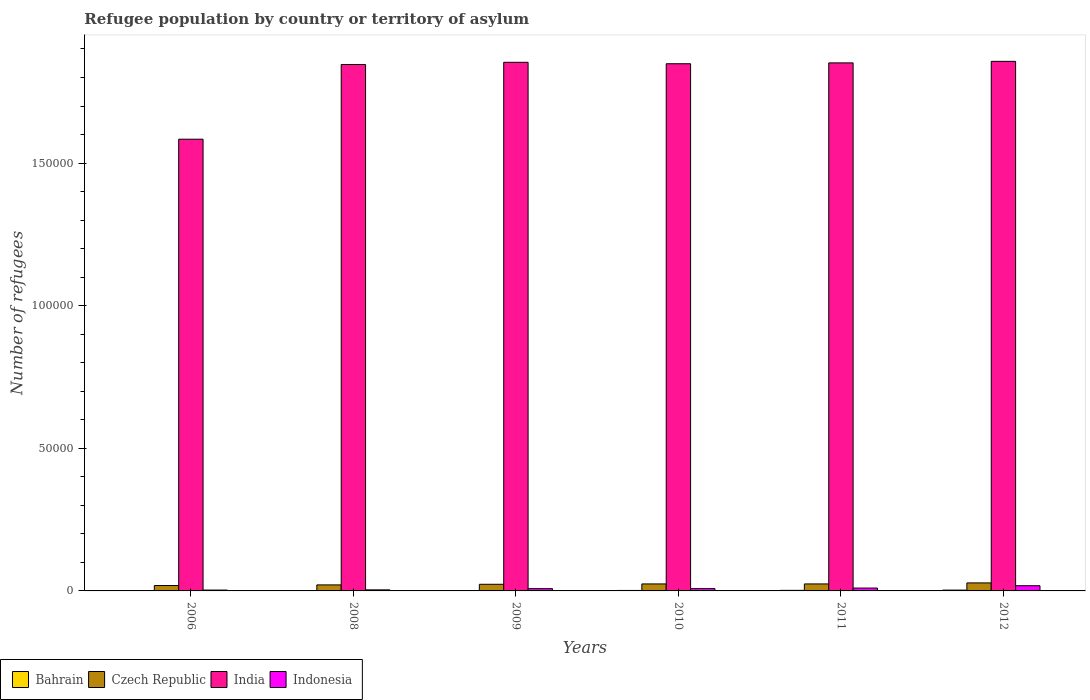How many different coloured bars are there?
Offer a very short reply. 4. How many groups of bars are there?
Offer a terse response. 6. Are the number of bars per tick equal to the number of legend labels?
Give a very brief answer. Yes. In how many cases, is the number of bars for a given year not equal to the number of legend labels?
Your answer should be compact. 0. What is the number of refugees in Indonesia in 2008?
Provide a succinct answer. 369. Across all years, what is the maximum number of refugees in Indonesia?
Your answer should be very brief. 1819. In which year was the number of refugees in Indonesia maximum?
Give a very brief answer. 2012. What is the total number of refugees in Indonesia in the graph?
Your response must be concise. 5104. What is the difference between the number of refugees in Indonesia in 2010 and that in 2011?
Your answer should be compact. -195. What is the difference between the number of refugees in Indonesia in 2009 and the number of refugees in India in 2012?
Keep it short and to the point. -1.85e+05. What is the average number of refugees in India per year?
Provide a succinct answer. 1.81e+05. In the year 2011, what is the difference between the number of refugees in Bahrain and number of refugees in India?
Ensure brevity in your answer.  -1.85e+05. What is the ratio of the number of refugees in Indonesia in 2009 to that in 2012?
Make the answer very short. 0.44. Is the difference between the number of refugees in Bahrain in 2008 and 2009 greater than the difference between the number of refugees in India in 2008 and 2009?
Ensure brevity in your answer.  Yes. What is the difference between the highest and the lowest number of refugees in Indonesia?
Your answer should be very brief. 1518. Is the sum of the number of refugees in Bahrain in 2010 and 2011 greater than the maximum number of refugees in Czech Republic across all years?
Offer a very short reply. No. Is it the case that in every year, the sum of the number of refugees in Indonesia and number of refugees in India is greater than the sum of number of refugees in Czech Republic and number of refugees in Bahrain?
Provide a short and direct response. No. What does the 4th bar from the right in 2011 represents?
Your answer should be compact. Bahrain. Is it the case that in every year, the sum of the number of refugees in India and number of refugees in Bahrain is greater than the number of refugees in Czech Republic?
Offer a very short reply. Yes. How many years are there in the graph?
Give a very brief answer. 6. What is the difference between two consecutive major ticks on the Y-axis?
Keep it short and to the point. 5.00e+04. Are the values on the major ticks of Y-axis written in scientific E-notation?
Offer a very short reply. No. Does the graph contain any zero values?
Your answer should be compact. No. Does the graph contain grids?
Your answer should be very brief. No. How many legend labels are there?
Make the answer very short. 4. How are the legend labels stacked?
Offer a terse response. Horizontal. What is the title of the graph?
Ensure brevity in your answer.  Refugee population by country or territory of asylum. What is the label or title of the Y-axis?
Give a very brief answer. Number of refugees. What is the Number of refugees in Czech Republic in 2006?
Offer a terse response. 1887. What is the Number of refugees of India in 2006?
Offer a terse response. 1.58e+05. What is the Number of refugees of Indonesia in 2006?
Offer a terse response. 301. What is the Number of refugees in Bahrain in 2008?
Provide a short and direct response. 48. What is the Number of refugees in Czech Republic in 2008?
Provide a succinct answer. 2110. What is the Number of refugees in India in 2008?
Your answer should be compact. 1.85e+05. What is the Number of refugees in Indonesia in 2008?
Your response must be concise. 369. What is the Number of refugees in Bahrain in 2009?
Your answer should be compact. 139. What is the Number of refugees of Czech Republic in 2009?
Your answer should be very brief. 2323. What is the Number of refugees in India in 2009?
Make the answer very short. 1.85e+05. What is the Number of refugees of Indonesia in 2009?
Ensure brevity in your answer.  798. What is the Number of refugees in Bahrain in 2010?
Ensure brevity in your answer.  165. What is the Number of refugees in Czech Republic in 2010?
Your answer should be very brief. 2449. What is the Number of refugees in India in 2010?
Provide a succinct answer. 1.85e+05. What is the Number of refugees in Indonesia in 2010?
Your answer should be compact. 811. What is the Number of refugees in Bahrain in 2011?
Keep it short and to the point. 199. What is the Number of refugees of Czech Republic in 2011?
Provide a succinct answer. 2449. What is the Number of refugees of India in 2011?
Offer a very short reply. 1.85e+05. What is the Number of refugees of Indonesia in 2011?
Your response must be concise. 1006. What is the Number of refugees in Bahrain in 2012?
Offer a very short reply. 289. What is the Number of refugees in Czech Republic in 2012?
Your response must be concise. 2805. What is the Number of refugees in India in 2012?
Offer a very short reply. 1.86e+05. What is the Number of refugees in Indonesia in 2012?
Offer a very short reply. 1819. Across all years, what is the maximum Number of refugees in Bahrain?
Your answer should be very brief. 289. Across all years, what is the maximum Number of refugees in Czech Republic?
Make the answer very short. 2805. Across all years, what is the maximum Number of refugees in India?
Offer a terse response. 1.86e+05. Across all years, what is the maximum Number of refugees in Indonesia?
Keep it short and to the point. 1819. Across all years, what is the minimum Number of refugees of Bahrain?
Provide a short and direct response. 1. Across all years, what is the minimum Number of refugees of Czech Republic?
Keep it short and to the point. 1887. Across all years, what is the minimum Number of refugees of India?
Ensure brevity in your answer.  1.58e+05. Across all years, what is the minimum Number of refugees in Indonesia?
Give a very brief answer. 301. What is the total Number of refugees in Bahrain in the graph?
Your answer should be compact. 841. What is the total Number of refugees in Czech Republic in the graph?
Provide a succinct answer. 1.40e+04. What is the total Number of refugees in India in the graph?
Offer a terse response. 1.08e+06. What is the total Number of refugees in Indonesia in the graph?
Keep it short and to the point. 5104. What is the difference between the Number of refugees in Bahrain in 2006 and that in 2008?
Make the answer very short. -47. What is the difference between the Number of refugees in Czech Republic in 2006 and that in 2008?
Provide a succinct answer. -223. What is the difference between the Number of refugees in India in 2006 and that in 2008?
Keep it short and to the point. -2.62e+04. What is the difference between the Number of refugees of Indonesia in 2006 and that in 2008?
Your response must be concise. -68. What is the difference between the Number of refugees of Bahrain in 2006 and that in 2009?
Your answer should be compact. -138. What is the difference between the Number of refugees in Czech Republic in 2006 and that in 2009?
Provide a succinct answer. -436. What is the difference between the Number of refugees in India in 2006 and that in 2009?
Give a very brief answer. -2.70e+04. What is the difference between the Number of refugees in Indonesia in 2006 and that in 2009?
Offer a terse response. -497. What is the difference between the Number of refugees in Bahrain in 2006 and that in 2010?
Your answer should be compact. -164. What is the difference between the Number of refugees in Czech Republic in 2006 and that in 2010?
Offer a very short reply. -562. What is the difference between the Number of refugees of India in 2006 and that in 2010?
Make the answer very short. -2.65e+04. What is the difference between the Number of refugees of Indonesia in 2006 and that in 2010?
Keep it short and to the point. -510. What is the difference between the Number of refugees in Bahrain in 2006 and that in 2011?
Your response must be concise. -198. What is the difference between the Number of refugees of Czech Republic in 2006 and that in 2011?
Offer a very short reply. -562. What is the difference between the Number of refugees of India in 2006 and that in 2011?
Your answer should be compact. -2.68e+04. What is the difference between the Number of refugees in Indonesia in 2006 and that in 2011?
Keep it short and to the point. -705. What is the difference between the Number of refugees of Bahrain in 2006 and that in 2012?
Give a very brief answer. -288. What is the difference between the Number of refugees in Czech Republic in 2006 and that in 2012?
Ensure brevity in your answer.  -918. What is the difference between the Number of refugees in India in 2006 and that in 2012?
Offer a very short reply. -2.73e+04. What is the difference between the Number of refugees in Indonesia in 2006 and that in 2012?
Provide a short and direct response. -1518. What is the difference between the Number of refugees in Bahrain in 2008 and that in 2009?
Your answer should be compact. -91. What is the difference between the Number of refugees of Czech Republic in 2008 and that in 2009?
Ensure brevity in your answer.  -213. What is the difference between the Number of refugees of India in 2008 and that in 2009?
Your response must be concise. -780. What is the difference between the Number of refugees in Indonesia in 2008 and that in 2009?
Provide a succinct answer. -429. What is the difference between the Number of refugees in Bahrain in 2008 and that in 2010?
Keep it short and to the point. -117. What is the difference between the Number of refugees in Czech Republic in 2008 and that in 2010?
Offer a terse response. -339. What is the difference between the Number of refugees in India in 2008 and that in 2010?
Offer a very short reply. -278. What is the difference between the Number of refugees of Indonesia in 2008 and that in 2010?
Provide a succinct answer. -442. What is the difference between the Number of refugees of Bahrain in 2008 and that in 2011?
Give a very brief answer. -151. What is the difference between the Number of refugees of Czech Republic in 2008 and that in 2011?
Your answer should be compact. -339. What is the difference between the Number of refugees in India in 2008 and that in 2011?
Provide a short and direct response. -575. What is the difference between the Number of refugees in Indonesia in 2008 and that in 2011?
Give a very brief answer. -637. What is the difference between the Number of refugees of Bahrain in 2008 and that in 2012?
Offer a very short reply. -241. What is the difference between the Number of refugees in Czech Republic in 2008 and that in 2012?
Make the answer very short. -695. What is the difference between the Number of refugees of India in 2008 and that in 2012?
Keep it short and to the point. -1113. What is the difference between the Number of refugees in Indonesia in 2008 and that in 2012?
Your response must be concise. -1450. What is the difference between the Number of refugees in Czech Republic in 2009 and that in 2010?
Your answer should be very brief. -126. What is the difference between the Number of refugees of India in 2009 and that in 2010?
Provide a succinct answer. 502. What is the difference between the Number of refugees in Bahrain in 2009 and that in 2011?
Your answer should be compact. -60. What is the difference between the Number of refugees in Czech Republic in 2009 and that in 2011?
Your answer should be very brief. -126. What is the difference between the Number of refugees in India in 2009 and that in 2011?
Keep it short and to the point. 205. What is the difference between the Number of refugees in Indonesia in 2009 and that in 2011?
Offer a very short reply. -208. What is the difference between the Number of refugees in Bahrain in 2009 and that in 2012?
Your answer should be very brief. -150. What is the difference between the Number of refugees in Czech Republic in 2009 and that in 2012?
Provide a short and direct response. -482. What is the difference between the Number of refugees of India in 2009 and that in 2012?
Keep it short and to the point. -333. What is the difference between the Number of refugees in Indonesia in 2009 and that in 2012?
Offer a very short reply. -1021. What is the difference between the Number of refugees of Bahrain in 2010 and that in 2011?
Your answer should be very brief. -34. What is the difference between the Number of refugees of Czech Republic in 2010 and that in 2011?
Offer a terse response. 0. What is the difference between the Number of refugees in India in 2010 and that in 2011?
Your answer should be compact. -297. What is the difference between the Number of refugees of Indonesia in 2010 and that in 2011?
Provide a short and direct response. -195. What is the difference between the Number of refugees in Bahrain in 2010 and that in 2012?
Ensure brevity in your answer.  -124. What is the difference between the Number of refugees of Czech Republic in 2010 and that in 2012?
Your answer should be compact. -356. What is the difference between the Number of refugees of India in 2010 and that in 2012?
Make the answer very short. -835. What is the difference between the Number of refugees in Indonesia in 2010 and that in 2012?
Provide a short and direct response. -1008. What is the difference between the Number of refugees of Bahrain in 2011 and that in 2012?
Your answer should be very brief. -90. What is the difference between the Number of refugees of Czech Republic in 2011 and that in 2012?
Your answer should be compact. -356. What is the difference between the Number of refugees of India in 2011 and that in 2012?
Offer a very short reply. -538. What is the difference between the Number of refugees of Indonesia in 2011 and that in 2012?
Keep it short and to the point. -813. What is the difference between the Number of refugees of Bahrain in 2006 and the Number of refugees of Czech Republic in 2008?
Provide a short and direct response. -2109. What is the difference between the Number of refugees of Bahrain in 2006 and the Number of refugees of India in 2008?
Offer a terse response. -1.85e+05. What is the difference between the Number of refugees in Bahrain in 2006 and the Number of refugees in Indonesia in 2008?
Provide a short and direct response. -368. What is the difference between the Number of refugees of Czech Republic in 2006 and the Number of refugees of India in 2008?
Your response must be concise. -1.83e+05. What is the difference between the Number of refugees of Czech Republic in 2006 and the Number of refugees of Indonesia in 2008?
Provide a succinct answer. 1518. What is the difference between the Number of refugees in India in 2006 and the Number of refugees in Indonesia in 2008?
Provide a short and direct response. 1.58e+05. What is the difference between the Number of refugees in Bahrain in 2006 and the Number of refugees in Czech Republic in 2009?
Your response must be concise. -2322. What is the difference between the Number of refugees of Bahrain in 2006 and the Number of refugees of India in 2009?
Keep it short and to the point. -1.85e+05. What is the difference between the Number of refugees of Bahrain in 2006 and the Number of refugees of Indonesia in 2009?
Your answer should be compact. -797. What is the difference between the Number of refugees of Czech Republic in 2006 and the Number of refugees of India in 2009?
Provide a short and direct response. -1.83e+05. What is the difference between the Number of refugees of Czech Republic in 2006 and the Number of refugees of Indonesia in 2009?
Provide a short and direct response. 1089. What is the difference between the Number of refugees in India in 2006 and the Number of refugees in Indonesia in 2009?
Offer a very short reply. 1.58e+05. What is the difference between the Number of refugees of Bahrain in 2006 and the Number of refugees of Czech Republic in 2010?
Give a very brief answer. -2448. What is the difference between the Number of refugees in Bahrain in 2006 and the Number of refugees in India in 2010?
Offer a terse response. -1.85e+05. What is the difference between the Number of refugees of Bahrain in 2006 and the Number of refugees of Indonesia in 2010?
Make the answer very short. -810. What is the difference between the Number of refugees of Czech Republic in 2006 and the Number of refugees of India in 2010?
Your answer should be compact. -1.83e+05. What is the difference between the Number of refugees of Czech Republic in 2006 and the Number of refugees of Indonesia in 2010?
Give a very brief answer. 1076. What is the difference between the Number of refugees in India in 2006 and the Number of refugees in Indonesia in 2010?
Your answer should be very brief. 1.58e+05. What is the difference between the Number of refugees in Bahrain in 2006 and the Number of refugees in Czech Republic in 2011?
Ensure brevity in your answer.  -2448. What is the difference between the Number of refugees in Bahrain in 2006 and the Number of refugees in India in 2011?
Keep it short and to the point. -1.85e+05. What is the difference between the Number of refugees in Bahrain in 2006 and the Number of refugees in Indonesia in 2011?
Your response must be concise. -1005. What is the difference between the Number of refugees in Czech Republic in 2006 and the Number of refugees in India in 2011?
Provide a succinct answer. -1.83e+05. What is the difference between the Number of refugees of Czech Republic in 2006 and the Number of refugees of Indonesia in 2011?
Provide a succinct answer. 881. What is the difference between the Number of refugees in India in 2006 and the Number of refugees in Indonesia in 2011?
Offer a terse response. 1.57e+05. What is the difference between the Number of refugees in Bahrain in 2006 and the Number of refugees in Czech Republic in 2012?
Your answer should be very brief. -2804. What is the difference between the Number of refugees of Bahrain in 2006 and the Number of refugees of India in 2012?
Provide a short and direct response. -1.86e+05. What is the difference between the Number of refugees of Bahrain in 2006 and the Number of refugees of Indonesia in 2012?
Offer a very short reply. -1818. What is the difference between the Number of refugees in Czech Republic in 2006 and the Number of refugees in India in 2012?
Provide a short and direct response. -1.84e+05. What is the difference between the Number of refugees in Czech Republic in 2006 and the Number of refugees in Indonesia in 2012?
Provide a short and direct response. 68. What is the difference between the Number of refugees in India in 2006 and the Number of refugees in Indonesia in 2012?
Offer a very short reply. 1.57e+05. What is the difference between the Number of refugees in Bahrain in 2008 and the Number of refugees in Czech Republic in 2009?
Your response must be concise. -2275. What is the difference between the Number of refugees of Bahrain in 2008 and the Number of refugees of India in 2009?
Offer a very short reply. -1.85e+05. What is the difference between the Number of refugees of Bahrain in 2008 and the Number of refugees of Indonesia in 2009?
Your answer should be very brief. -750. What is the difference between the Number of refugees in Czech Republic in 2008 and the Number of refugees in India in 2009?
Offer a terse response. -1.83e+05. What is the difference between the Number of refugees in Czech Republic in 2008 and the Number of refugees in Indonesia in 2009?
Ensure brevity in your answer.  1312. What is the difference between the Number of refugees in India in 2008 and the Number of refugees in Indonesia in 2009?
Keep it short and to the point. 1.84e+05. What is the difference between the Number of refugees of Bahrain in 2008 and the Number of refugees of Czech Republic in 2010?
Provide a succinct answer. -2401. What is the difference between the Number of refugees of Bahrain in 2008 and the Number of refugees of India in 2010?
Provide a short and direct response. -1.85e+05. What is the difference between the Number of refugees of Bahrain in 2008 and the Number of refugees of Indonesia in 2010?
Provide a succinct answer. -763. What is the difference between the Number of refugees of Czech Republic in 2008 and the Number of refugees of India in 2010?
Your answer should be compact. -1.83e+05. What is the difference between the Number of refugees of Czech Republic in 2008 and the Number of refugees of Indonesia in 2010?
Give a very brief answer. 1299. What is the difference between the Number of refugees of India in 2008 and the Number of refugees of Indonesia in 2010?
Keep it short and to the point. 1.84e+05. What is the difference between the Number of refugees in Bahrain in 2008 and the Number of refugees in Czech Republic in 2011?
Your response must be concise. -2401. What is the difference between the Number of refugees of Bahrain in 2008 and the Number of refugees of India in 2011?
Keep it short and to the point. -1.85e+05. What is the difference between the Number of refugees of Bahrain in 2008 and the Number of refugees of Indonesia in 2011?
Give a very brief answer. -958. What is the difference between the Number of refugees in Czech Republic in 2008 and the Number of refugees in India in 2011?
Your answer should be compact. -1.83e+05. What is the difference between the Number of refugees in Czech Republic in 2008 and the Number of refugees in Indonesia in 2011?
Keep it short and to the point. 1104. What is the difference between the Number of refugees of India in 2008 and the Number of refugees of Indonesia in 2011?
Keep it short and to the point. 1.84e+05. What is the difference between the Number of refugees of Bahrain in 2008 and the Number of refugees of Czech Republic in 2012?
Your answer should be very brief. -2757. What is the difference between the Number of refugees in Bahrain in 2008 and the Number of refugees in India in 2012?
Keep it short and to the point. -1.86e+05. What is the difference between the Number of refugees in Bahrain in 2008 and the Number of refugees in Indonesia in 2012?
Make the answer very short. -1771. What is the difference between the Number of refugees in Czech Republic in 2008 and the Number of refugees in India in 2012?
Your answer should be very brief. -1.84e+05. What is the difference between the Number of refugees in Czech Republic in 2008 and the Number of refugees in Indonesia in 2012?
Your response must be concise. 291. What is the difference between the Number of refugees of India in 2008 and the Number of refugees of Indonesia in 2012?
Provide a succinct answer. 1.83e+05. What is the difference between the Number of refugees of Bahrain in 2009 and the Number of refugees of Czech Republic in 2010?
Provide a succinct answer. -2310. What is the difference between the Number of refugees in Bahrain in 2009 and the Number of refugees in India in 2010?
Keep it short and to the point. -1.85e+05. What is the difference between the Number of refugees in Bahrain in 2009 and the Number of refugees in Indonesia in 2010?
Give a very brief answer. -672. What is the difference between the Number of refugees in Czech Republic in 2009 and the Number of refugees in India in 2010?
Provide a succinct answer. -1.82e+05. What is the difference between the Number of refugees of Czech Republic in 2009 and the Number of refugees of Indonesia in 2010?
Make the answer very short. 1512. What is the difference between the Number of refugees of India in 2009 and the Number of refugees of Indonesia in 2010?
Offer a very short reply. 1.85e+05. What is the difference between the Number of refugees in Bahrain in 2009 and the Number of refugees in Czech Republic in 2011?
Provide a short and direct response. -2310. What is the difference between the Number of refugees of Bahrain in 2009 and the Number of refugees of India in 2011?
Ensure brevity in your answer.  -1.85e+05. What is the difference between the Number of refugees of Bahrain in 2009 and the Number of refugees of Indonesia in 2011?
Provide a succinct answer. -867. What is the difference between the Number of refugees of Czech Republic in 2009 and the Number of refugees of India in 2011?
Provide a short and direct response. -1.83e+05. What is the difference between the Number of refugees in Czech Republic in 2009 and the Number of refugees in Indonesia in 2011?
Your answer should be compact. 1317. What is the difference between the Number of refugees in India in 2009 and the Number of refugees in Indonesia in 2011?
Provide a succinct answer. 1.84e+05. What is the difference between the Number of refugees of Bahrain in 2009 and the Number of refugees of Czech Republic in 2012?
Your response must be concise. -2666. What is the difference between the Number of refugees of Bahrain in 2009 and the Number of refugees of India in 2012?
Your answer should be very brief. -1.86e+05. What is the difference between the Number of refugees in Bahrain in 2009 and the Number of refugees in Indonesia in 2012?
Provide a short and direct response. -1680. What is the difference between the Number of refugees of Czech Republic in 2009 and the Number of refugees of India in 2012?
Ensure brevity in your answer.  -1.83e+05. What is the difference between the Number of refugees of Czech Republic in 2009 and the Number of refugees of Indonesia in 2012?
Provide a succinct answer. 504. What is the difference between the Number of refugees in India in 2009 and the Number of refugees in Indonesia in 2012?
Give a very brief answer. 1.84e+05. What is the difference between the Number of refugees of Bahrain in 2010 and the Number of refugees of Czech Republic in 2011?
Offer a terse response. -2284. What is the difference between the Number of refugees of Bahrain in 2010 and the Number of refugees of India in 2011?
Provide a succinct answer. -1.85e+05. What is the difference between the Number of refugees in Bahrain in 2010 and the Number of refugees in Indonesia in 2011?
Offer a terse response. -841. What is the difference between the Number of refugees of Czech Republic in 2010 and the Number of refugees of India in 2011?
Provide a succinct answer. -1.83e+05. What is the difference between the Number of refugees of Czech Republic in 2010 and the Number of refugees of Indonesia in 2011?
Your response must be concise. 1443. What is the difference between the Number of refugees in India in 2010 and the Number of refugees in Indonesia in 2011?
Provide a succinct answer. 1.84e+05. What is the difference between the Number of refugees of Bahrain in 2010 and the Number of refugees of Czech Republic in 2012?
Your answer should be very brief. -2640. What is the difference between the Number of refugees of Bahrain in 2010 and the Number of refugees of India in 2012?
Your answer should be compact. -1.85e+05. What is the difference between the Number of refugees in Bahrain in 2010 and the Number of refugees in Indonesia in 2012?
Make the answer very short. -1654. What is the difference between the Number of refugees in Czech Republic in 2010 and the Number of refugees in India in 2012?
Your answer should be very brief. -1.83e+05. What is the difference between the Number of refugees in Czech Republic in 2010 and the Number of refugees in Indonesia in 2012?
Offer a very short reply. 630. What is the difference between the Number of refugees of India in 2010 and the Number of refugees of Indonesia in 2012?
Make the answer very short. 1.83e+05. What is the difference between the Number of refugees in Bahrain in 2011 and the Number of refugees in Czech Republic in 2012?
Give a very brief answer. -2606. What is the difference between the Number of refugees of Bahrain in 2011 and the Number of refugees of India in 2012?
Provide a succinct answer. -1.85e+05. What is the difference between the Number of refugees of Bahrain in 2011 and the Number of refugees of Indonesia in 2012?
Keep it short and to the point. -1620. What is the difference between the Number of refugees of Czech Republic in 2011 and the Number of refugees of India in 2012?
Give a very brief answer. -1.83e+05. What is the difference between the Number of refugees in Czech Republic in 2011 and the Number of refugees in Indonesia in 2012?
Ensure brevity in your answer.  630. What is the difference between the Number of refugees in India in 2011 and the Number of refugees in Indonesia in 2012?
Provide a short and direct response. 1.83e+05. What is the average Number of refugees of Bahrain per year?
Keep it short and to the point. 140.17. What is the average Number of refugees of Czech Republic per year?
Offer a terse response. 2337.17. What is the average Number of refugees in India per year?
Offer a very short reply. 1.81e+05. What is the average Number of refugees in Indonesia per year?
Give a very brief answer. 850.67. In the year 2006, what is the difference between the Number of refugees of Bahrain and Number of refugees of Czech Republic?
Ensure brevity in your answer.  -1886. In the year 2006, what is the difference between the Number of refugees of Bahrain and Number of refugees of India?
Ensure brevity in your answer.  -1.58e+05. In the year 2006, what is the difference between the Number of refugees of Bahrain and Number of refugees of Indonesia?
Your answer should be very brief. -300. In the year 2006, what is the difference between the Number of refugees of Czech Republic and Number of refugees of India?
Your response must be concise. -1.56e+05. In the year 2006, what is the difference between the Number of refugees of Czech Republic and Number of refugees of Indonesia?
Your response must be concise. 1586. In the year 2006, what is the difference between the Number of refugees in India and Number of refugees in Indonesia?
Ensure brevity in your answer.  1.58e+05. In the year 2008, what is the difference between the Number of refugees of Bahrain and Number of refugees of Czech Republic?
Offer a very short reply. -2062. In the year 2008, what is the difference between the Number of refugees of Bahrain and Number of refugees of India?
Make the answer very short. -1.84e+05. In the year 2008, what is the difference between the Number of refugees in Bahrain and Number of refugees in Indonesia?
Make the answer very short. -321. In the year 2008, what is the difference between the Number of refugees in Czech Republic and Number of refugees in India?
Make the answer very short. -1.82e+05. In the year 2008, what is the difference between the Number of refugees of Czech Republic and Number of refugees of Indonesia?
Offer a very short reply. 1741. In the year 2008, what is the difference between the Number of refugees in India and Number of refugees in Indonesia?
Ensure brevity in your answer.  1.84e+05. In the year 2009, what is the difference between the Number of refugees in Bahrain and Number of refugees in Czech Republic?
Keep it short and to the point. -2184. In the year 2009, what is the difference between the Number of refugees in Bahrain and Number of refugees in India?
Your answer should be compact. -1.85e+05. In the year 2009, what is the difference between the Number of refugees of Bahrain and Number of refugees of Indonesia?
Your answer should be compact. -659. In the year 2009, what is the difference between the Number of refugees of Czech Republic and Number of refugees of India?
Your answer should be very brief. -1.83e+05. In the year 2009, what is the difference between the Number of refugees of Czech Republic and Number of refugees of Indonesia?
Provide a short and direct response. 1525. In the year 2009, what is the difference between the Number of refugees of India and Number of refugees of Indonesia?
Your response must be concise. 1.85e+05. In the year 2010, what is the difference between the Number of refugees in Bahrain and Number of refugees in Czech Republic?
Provide a succinct answer. -2284. In the year 2010, what is the difference between the Number of refugees in Bahrain and Number of refugees in India?
Keep it short and to the point. -1.85e+05. In the year 2010, what is the difference between the Number of refugees of Bahrain and Number of refugees of Indonesia?
Provide a succinct answer. -646. In the year 2010, what is the difference between the Number of refugees in Czech Republic and Number of refugees in India?
Provide a succinct answer. -1.82e+05. In the year 2010, what is the difference between the Number of refugees in Czech Republic and Number of refugees in Indonesia?
Give a very brief answer. 1638. In the year 2010, what is the difference between the Number of refugees in India and Number of refugees in Indonesia?
Your response must be concise. 1.84e+05. In the year 2011, what is the difference between the Number of refugees in Bahrain and Number of refugees in Czech Republic?
Provide a short and direct response. -2250. In the year 2011, what is the difference between the Number of refugees in Bahrain and Number of refugees in India?
Your response must be concise. -1.85e+05. In the year 2011, what is the difference between the Number of refugees in Bahrain and Number of refugees in Indonesia?
Ensure brevity in your answer.  -807. In the year 2011, what is the difference between the Number of refugees of Czech Republic and Number of refugees of India?
Keep it short and to the point. -1.83e+05. In the year 2011, what is the difference between the Number of refugees in Czech Republic and Number of refugees in Indonesia?
Offer a very short reply. 1443. In the year 2011, what is the difference between the Number of refugees in India and Number of refugees in Indonesia?
Provide a short and direct response. 1.84e+05. In the year 2012, what is the difference between the Number of refugees in Bahrain and Number of refugees in Czech Republic?
Make the answer very short. -2516. In the year 2012, what is the difference between the Number of refugees in Bahrain and Number of refugees in India?
Offer a terse response. -1.85e+05. In the year 2012, what is the difference between the Number of refugees in Bahrain and Number of refugees in Indonesia?
Ensure brevity in your answer.  -1530. In the year 2012, what is the difference between the Number of refugees in Czech Republic and Number of refugees in India?
Your answer should be very brief. -1.83e+05. In the year 2012, what is the difference between the Number of refugees in Czech Republic and Number of refugees in Indonesia?
Provide a short and direct response. 986. In the year 2012, what is the difference between the Number of refugees in India and Number of refugees in Indonesia?
Your response must be concise. 1.84e+05. What is the ratio of the Number of refugees of Bahrain in 2006 to that in 2008?
Offer a very short reply. 0.02. What is the ratio of the Number of refugees in Czech Republic in 2006 to that in 2008?
Your answer should be compact. 0.89. What is the ratio of the Number of refugees of India in 2006 to that in 2008?
Make the answer very short. 0.86. What is the ratio of the Number of refugees in Indonesia in 2006 to that in 2008?
Your response must be concise. 0.82. What is the ratio of the Number of refugees of Bahrain in 2006 to that in 2009?
Ensure brevity in your answer.  0.01. What is the ratio of the Number of refugees in Czech Republic in 2006 to that in 2009?
Give a very brief answer. 0.81. What is the ratio of the Number of refugees in India in 2006 to that in 2009?
Your response must be concise. 0.85. What is the ratio of the Number of refugees in Indonesia in 2006 to that in 2009?
Give a very brief answer. 0.38. What is the ratio of the Number of refugees of Bahrain in 2006 to that in 2010?
Provide a short and direct response. 0.01. What is the ratio of the Number of refugees of Czech Republic in 2006 to that in 2010?
Offer a very short reply. 0.77. What is the ratio of the Number of refugees in India in 2006 to that in 2010?
Your answer should be compact. 0.86. What is the ratio of the Number of refugees in Indonesia in 2006 to that in 2010?
Offer a very short reply. 0.37. What is the ratio of the Number of refugees of Bahrain in 2006 to that in 2011?
Give a very brief answer. 0.01. What is the ratio of the Number of refugees in Czech Republic in 2006 to that in 2011?
Ensure brevity in your answer.  0.77. What is the ratio of the Number of refugees of India in 2006 to that in 2011?
Keep it short and to the point. 0.86. What is the ratio of the Number of refugees of Indonesia in 2006 to that in 2011?
Offer a very short reply. 0.3. What is the ratio of the Number of refugees of Bahrain in 2006 to that in 2012?
Provide a short and direct response. 0. What is the ratio of the Number of refugees of Czech Republic in 2006 to that in 2012?
Offer a very short reply. 0.67. What is the ratio of the Number of refugees of India in 2006 to that in 2012?
Your response must be concise. 0.85. What is the ratio of the Number of refugees of Indonesia in 2006 to that in 2012?
Provide a short and direct response. 0.17. What is the ratio of the Number of refugees in Bahrain in 2008 to that in 2009?
Provide a succinct answer. 0.35. What is the ratio of the Number of refugees of Czech Republic in 2008 to that in 2009?
Offer a very short reply. 0.91. What is the ratio of the Number of refugees of Indonesia in 2008 to that in 2009?
Offer a terse response. 0.46. What is the ratio of the Number of refugees in Bahrain in 2008 to that in 2010?
Provide a succinct answer. 0.29. What is the ratio of the Number of refugees of Czech Republic in 2008 to that in 2010?
Provide a short and direct response. 0.86. What is the ratio of the Number of refugees in Indonesia in 2008 to that in 2010?
Provide a succinct answer. 0.46. What is the ratio of the Number of refugees in Bahrain in 2008 to that in 2011?
Your response must be concise. 0.24. What is the ratio of the Number of refugees in Czech Republic in 2008 to that in 2011?
Make the answer very short. 0.86. What is the ratio of the Number of refugees in India in 2008 to that in 2011?
Your answer should be very brief. 1. What is the ratio of the Number of refugees of Indonesia in 2008 to that in 2011?
Keep it short and to the point. 0.37. What is the ratio of the Number of refugees in Bahrain in 2008 to that in 2012?
Your answer should be compact. 0.17. What is the ratio of the Number of refugees of Czech Republic in 2008 to that in 2012?
Your answer should be compact. 0.75. What is the ratio of the Number of refugees in Indonesia in 2008 to that in 2012?
Your answer should be compact. 0.2. What is the ratio of the Number of refugees in Bahrain in 2009 to that in 2010?
Provide a succinct answer. 0.84. What is the ratio of the Number of refugees in Czech Republic in 2009 to that in 2010?
Provide a succinct answer. 0.95. What is the ratio of the Number of refugees of Bahrain in 2009 to that in 2011?
Your answer should be compact. 0.7. What is the ratio of the Number of refugees of Czech Republic in 2009 to that in 2011?
Provide a succinct answer. 0.95. What is the ratio of the Number of refugees of India in 2009 to that in 2011?
Your answer should be compact. 1. What is the ratio of the Number of refugees of Indonesia in 2009 to that in 2011?
Your answer should be compact. 0.79. What is the ratio of the Number of refugees of Bahrain in 2009 to that in 2012?
Offer a terse response. 0.48. What is the ratio of the Number of refugees of Czech Republic in 2009 to that in 2012?
Make the answer very short. 0.83. What is the ratio of the Number of refugees in Indonesia in 2009 to that in 2012?
Your response must be concise. 0.44. What is the ratio of the Number of refugees of Bahrain in 2010 to that in 2011?
Keep it short and to the point. 0.83. What is the ratio of the Number of refugees in Czech Republic in 2010 to that in 2011?
Make the answer very short. 1. What is the ratio of the Number of refugees of India in 2010 to that in 2011?
Ensure brevity in your answer.  1. What is the ratio of the Number of refugees of Indonesia in 2010 to that in 2011?
Give a very brief answer. 0.81. What is the ratio of the Number of refugees in Bahrain in 2010 to that in 2012?
Your answer should be very brief. 0.57. What is the ratio of the Number of refugees of Czech Republic in 2010 to that in 2012?
Keep it short and to the point. 0.87. What is the ratio of the Number of refugees of Indonesia in 2010 to that in 2012?
Ensure brevity in your answer.  0.45. What is the ratio of the Number of refugees of Bahrain in 2011 to that in 2012?
Your response must be concise. 0.69. What is the ratio of the Number of refugees of Czech Republic in 2011 to that in 2012?
Your answer should be very brief. 0.87. What is the ratio of the Number of refugees of India in 2011 to that in 2012?
Your answer should be very brief. 1. What is the ratio of the Number of refugees of Indonesia in 2011 to that in 2012?
Provide a succinct answer. 0.55. What is the difference between the highest and the second highest Number of refugees of Bahrain?
Provide a short and direct response. 90. What is the difference between the highest and the second highest Number of refugees in Czech Republic?
Offer a terse response. 356. What is the difference between the highest and the second highest Number of refugees of India?
Your response must be concise. 333. What is the difference between the highest and the second highest Number of refugees of Indonesia?
Provide a short and direct response. 813. What is the difference between the highest and the lowest Number of refugees of Bahrain?
Offer a very short reply. 288. What is the difference between the highest and the lowest Number of refugees in Czech Republic?
Make the answer very short. 918. What is the difference between the highest and the lowest Number of refugees in India?
Provide a succinct answer. 2.73e+04. What is the difference between the highest and the lowest Number of refugees of Indonesia?
Your answer should be very brief. 1518. 